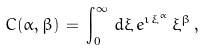Convert formula to latex. <formula><loc_0><loc_0><loc_500><loc_500>C ( \alpha , \beta ) \, = \, \int _ { 0 } ^ { \infty } \, d \xi \, e ^ { \imath \, \xi ^ { \alpha } } \, \xi ^ { \beta } \, ,</formula> 